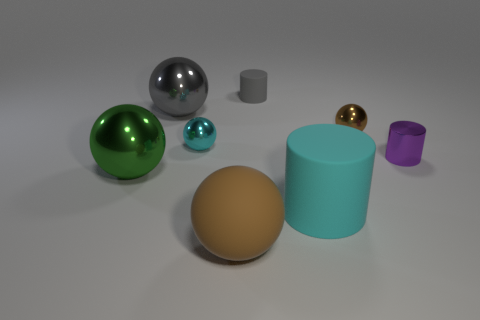There is a cyan object that is in front of the metallic cylinder; are there any brown matte objects behind it?
Provide a succinct answer. No. There is a matte object behind the sphere on the right side of the big cyan cylinder; how many large cyan matte objects are left of it?
Give a very brief answer. 0. Is the number of purple shiny objects less than the number of big blue metal balls?
Offer a terse response. No. Does the brown object that is in front of the green shiny sphere have the same shape as the cyan thing behind the green ball?
Provide a short and direct response. Yes. What color is the rubber sphere?
Offer a terse response. Brown. How many metallic objects are large gray cylinders or cyan things?
Your response must be concise. 1. There is a matte thing that is the same shape as the small cyan metallic thing; what color is it?
Offer a terse response. Brown. Is there a large gray metal cylinder?
Ensure brevity in your answer.  No. Do the large ball in front of the large green shiny thing and the big ball that is behind the purple object have the same material?
Make the answer very short. No. There is a big object that is the same color as the small rubber cylinder; what is its shape?
Make the answer very short. Sphere. 